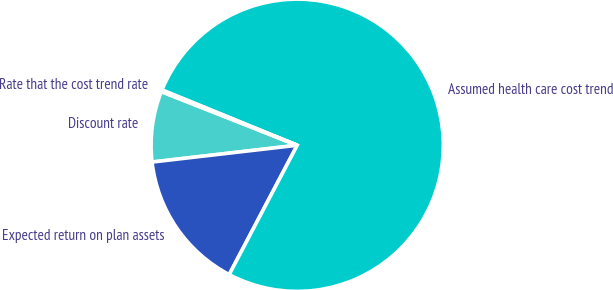Convert chart. <chart><loc_0><loc_0><loc_500><loc_500><pie_chart><fcel>Discount rate<fcel>Expected return on plan assets<fcel>Assumed health care cost trend<fcel>Rate that the cost trend rate<nl><fcel>7.82%<fcel>15.46%<fcel>76.53%<fcel>0.19%<nl></chart> 